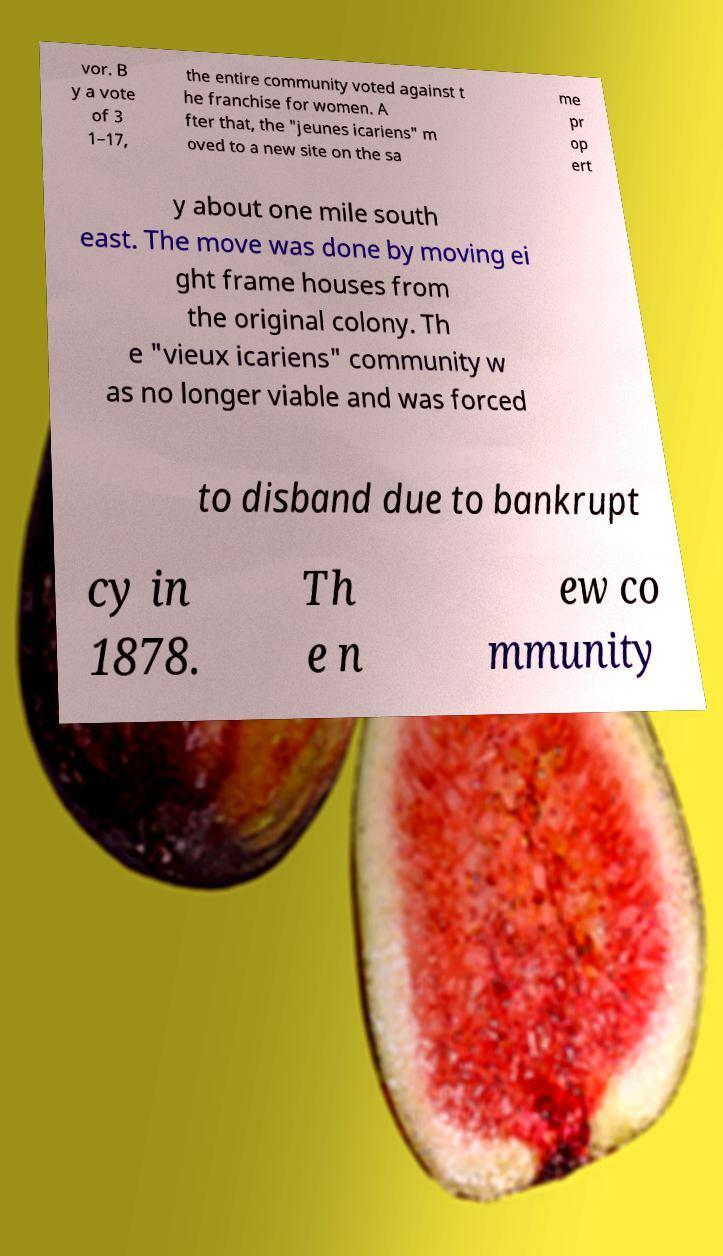Please identify and transcribe the text found in this image. vor. B y a vote of 3 1–17, the entire community voted against t he franchise for women. A fter that, the "jeunes icariens" m oved to a new site on the sa me pr op ert y about one mile south east. The move was done by moving ei ght frame houses from the original colony. Th e "vieux icariens" community w as no longer viable and was forced to disband due to bankrupt cy in 1878. Th e n ew co mmunity 